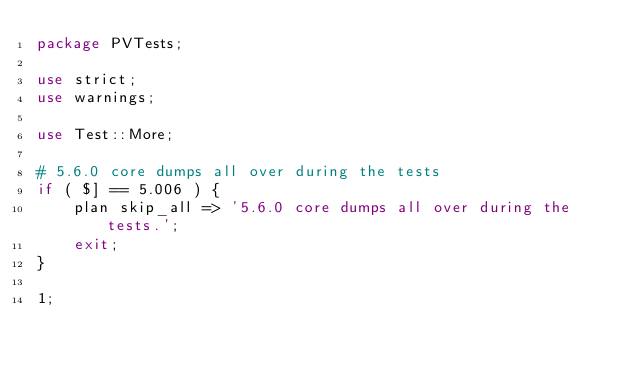Convert code to text. <code><loc_0><loc_0><loc_500><loc_500><_Perl_>package PVTests;

use strict;
use warnings;

use Test::More;

# 5.6.0 core dumps all over during the tests
if ( $] == 5.006 ) {
    plan skip_all => '5.6.0 core dumps all over during the tests.';
    exit;
}

1;
</code> 